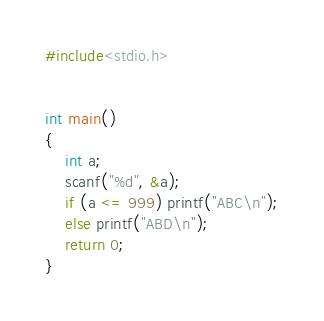Convert code to text. <code><loc_0><loc_0><loc_500><loc_500><_C++_>#include<stdio.h>


int main()
{
	int a;
	scanf("%d", &a);
	if (a <= 999) printf("ABC\n");
	else printf("ABD\n");
	return 0;
}</code> 